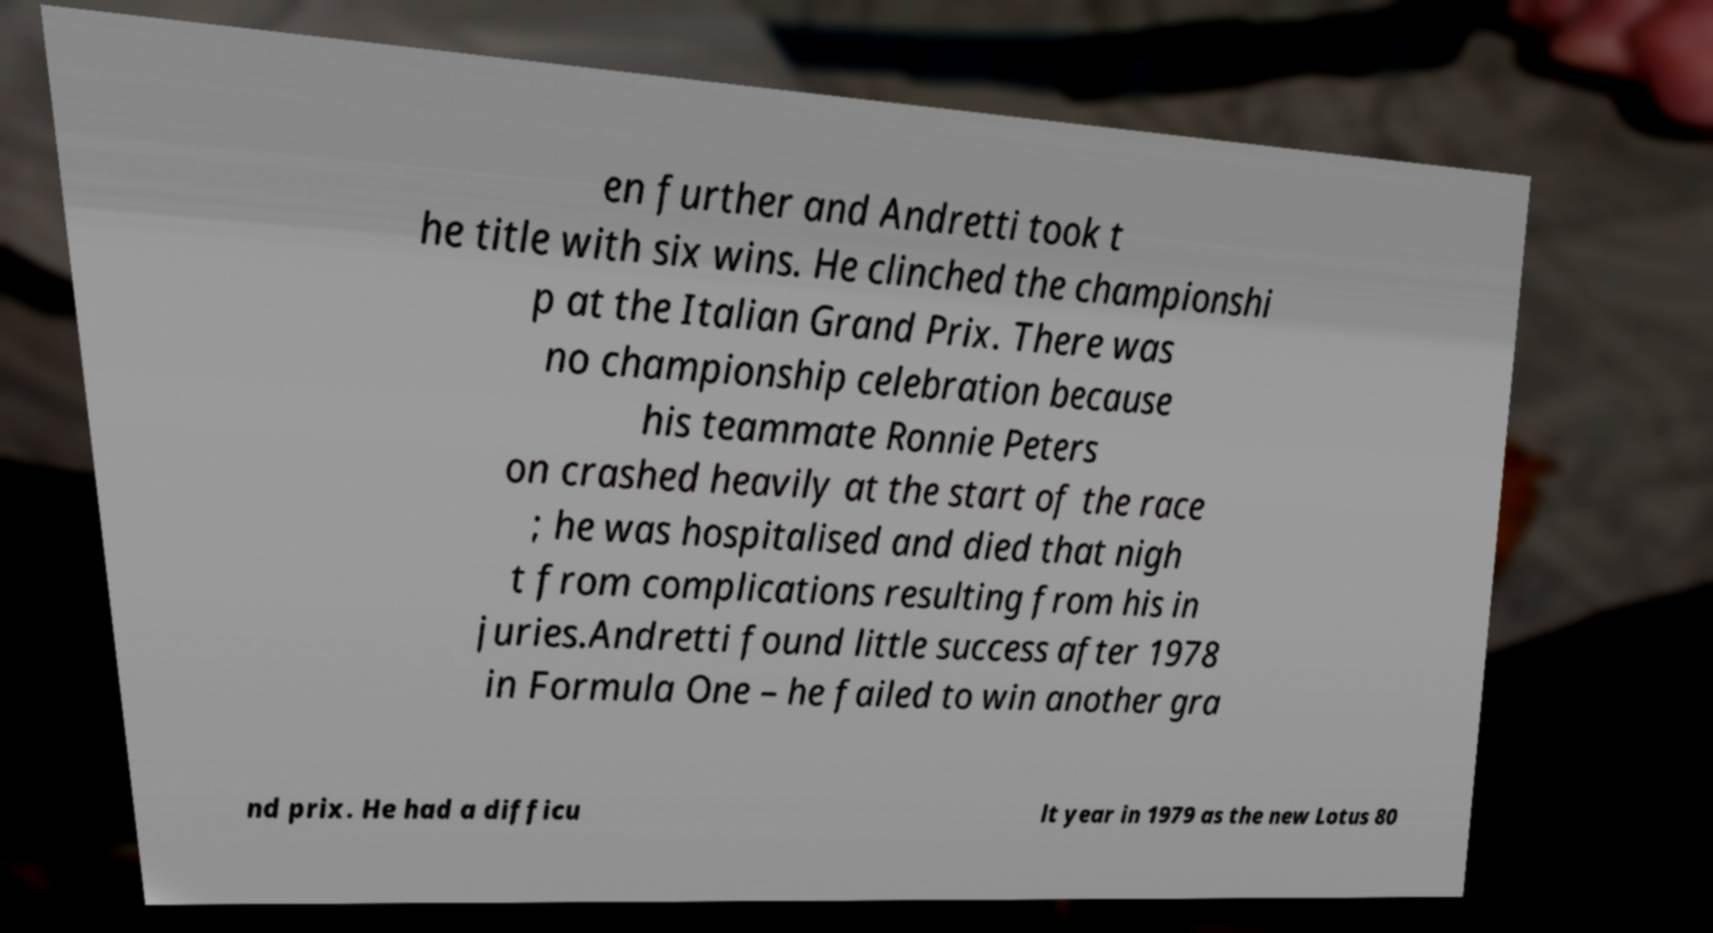Please read and relay the text visible in this image. What does it say? en further and Andretti took t he title with six wins. He clinched the championshi p at the Italian Grand Prix. There was no championship celebration because his teammate Ronnie Peters on crashed heavily at the start of the race ; he was hospitalised and died that nigh t from complications resulting from his in juries.Andretti found little success after 1978 in Formula One – he failed to win another gra nd prix. He had a difficu lt year in 1979 as the new Lotus 80 